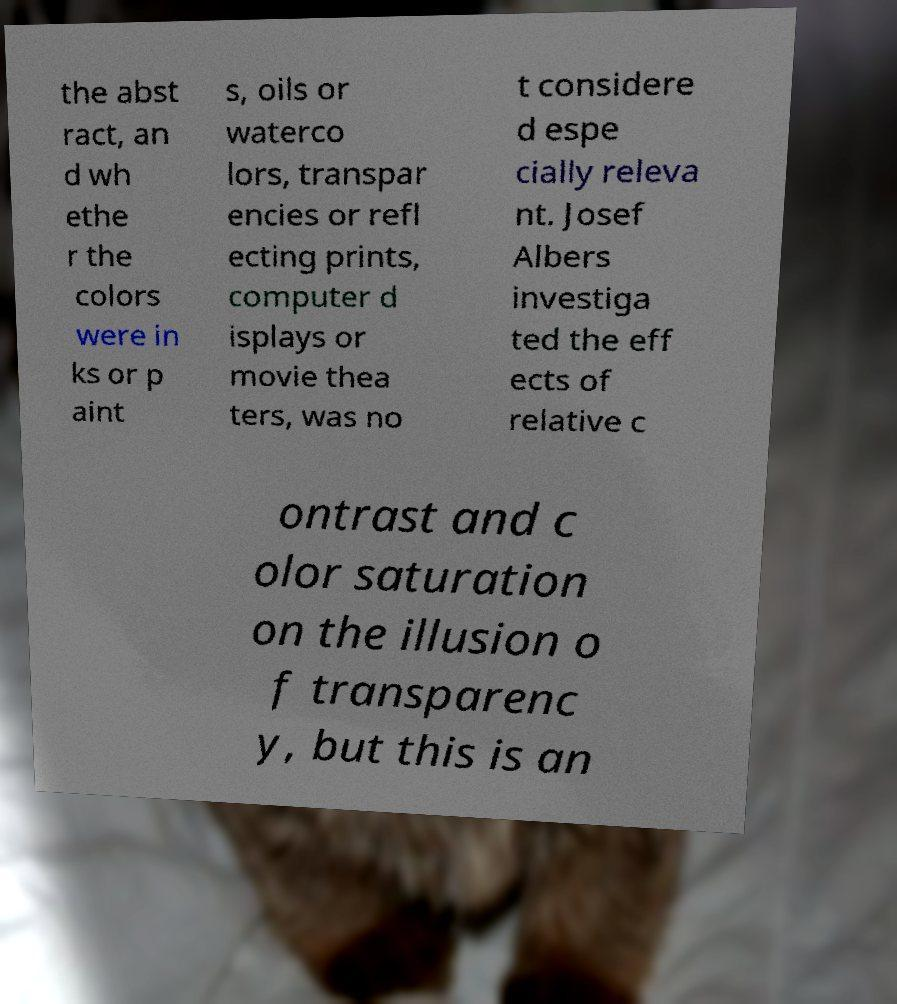Please read and relay the text visible in this image. What does it say? the abst ract, an d wh ethe r the colors were in ks or p aint s, oils or waterco lors, transpar encies or refl ecting prints, computer d isplays or movie thea ters, was no t considere d espe cially releva nt. Josef Albers investiga ted the eff ects of relative c ontrast and c olor saturation on the illusion o f transparenc y, but this is an 